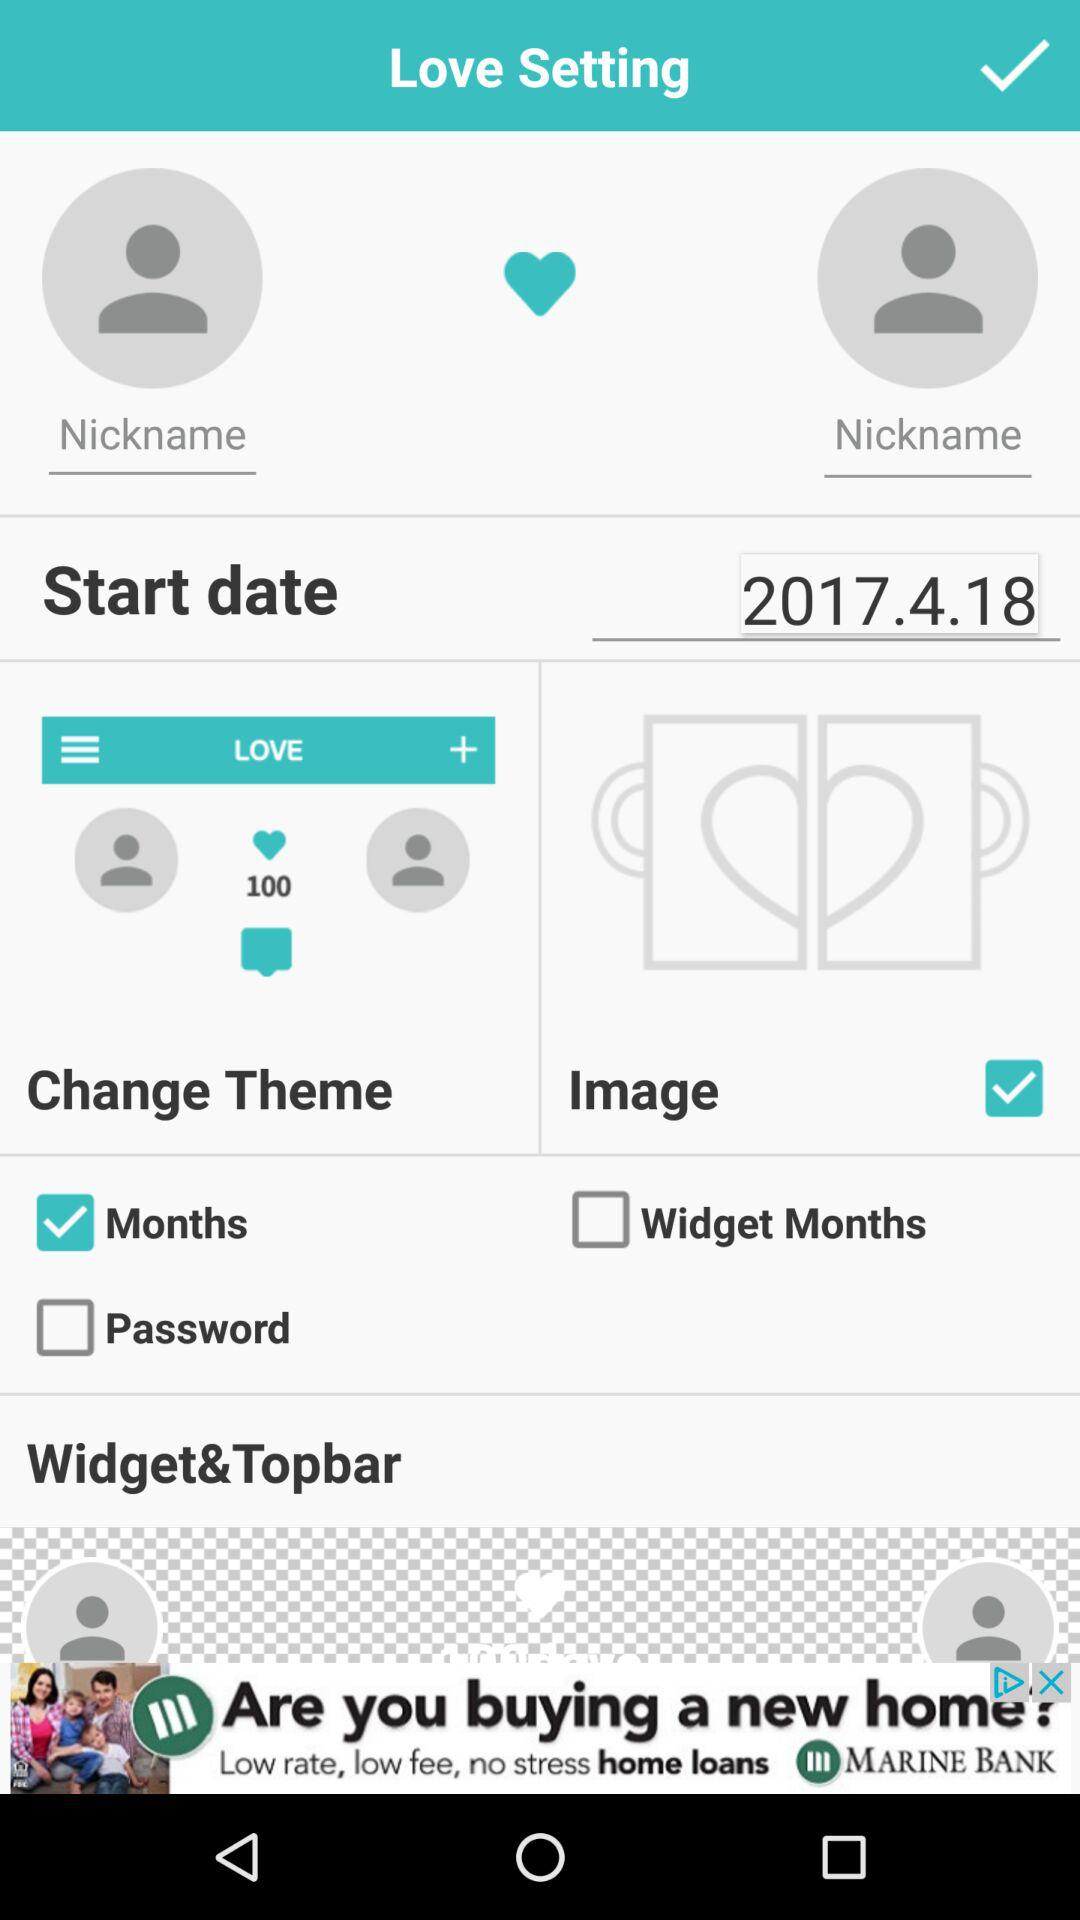Which love setting options are unchecked? The unchecked options are "Widget Months" and "Password". 